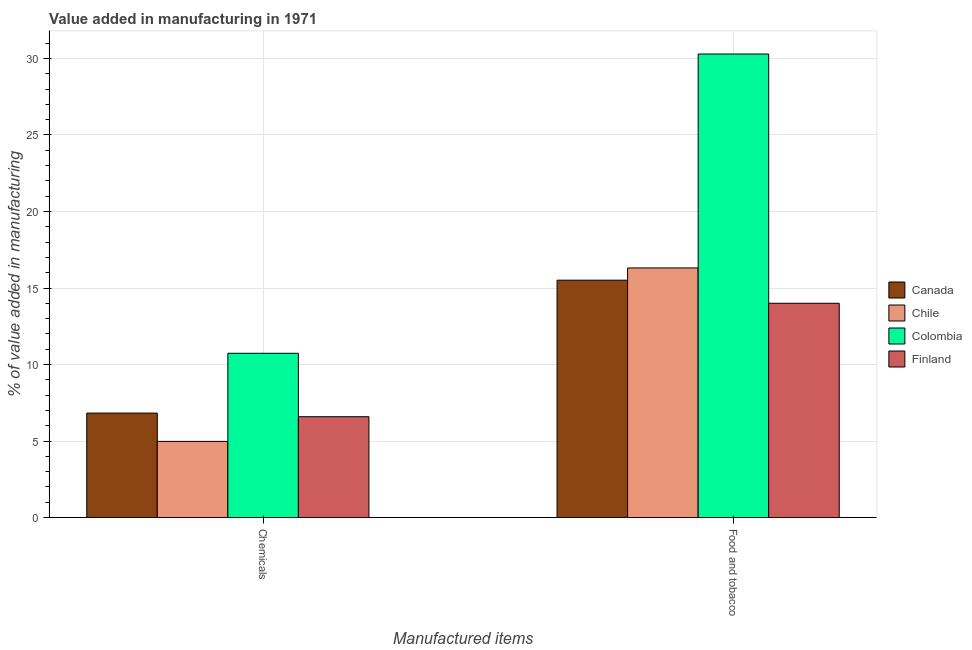How many different coloured bars are there?
Your answer should be very brief. 4. How many bars are there on the 2nd tick from the right?
Offer a terse response. 4. What is the label of the 1st group of bars from the left?
Provide a short and direct response. Chemicals. What is the value added by  manufacturing chemicals in Canada?
Ensure brevity in your answer.  6.83. Across all countries, what is the maximum value added by manufacturing food and tobacco?
Your response must be concise. 30.29. Across all countries, what is the minimum value added by manufacturing food and tobacco?
Ensure brevity in your answer.  14. In which country was the value added by  manufacturing chemicals maximum?
Your response must be concise. Colombia. In which country was the value added by  manufacturing chemicals minimum?
Give a very brief answer. Chile. What is the total value added by  manufacturing chemicals in the graph?
Your response must be concise. 29.13. What is the difference between the value added by manufacturing food and tobacco in Colombia and that in Canada?
Your response must be concise. 14.78. What is the difference between the value added by  manufacturing chemicals in Canada and the value added by manufacturing food and tobacco in Finland?
Give a very brief answer. -7.18. What is the average value added by  manufacturing chemicals per country?
Make the answer very short. 7.28. What is the difference between the value added by  manufacturing chemicals and value added by manufacturing food and tobacco in Finland?
Offer a very short reply. -7.41. In how many countries, is the value added by manufacturing food and tobacco greater than 6 %?
Give a very brief answer. 4. What is the ratio of the value added by  manufacturing chemicals in Chile to that in Colombia?
Give a very brief answer. 0.46. In how many countries, is the value added by manufacturing food and tobacco greater than the average value added by manufacturing food and tobacco taken over all countries?
Your response must be concise. 1. What does the 2nd bar from the left in Chemicals represents?
Provide a short and direct response. Chile. How many bars are there?
Make the answer very short. 8. What is the difference between two consecutive major ticks on the Y-axis?
Offer a terse response. 5. Does the graph contain grids?
Keep it short and to the point. Yes. What is the title of the graph?
Offer a very short reply. Value added in manufacturing in 1971. What is the label or title of the X-axis?
Offer a very short reply. Manufactured items. What is the label or title of the Y-axis?
Keep it short and to the point. % of value added in manufacturing. What is the % of value added in manufacturing of Canada in Chemicals?
Provide a short and direct response. 6.83. What is the % of value added in manufacturing in Chile in Chemicals?
Your answer should be compact. 4.98. What is the % of value added in manufacturing of Colombia in Chemicals?
Keep it short and to the point. 10.73. What is the % of value added in manufacturing of Finland in Chemicals?
Keep it short and to the point. 6.59. What is the % of value added in manufacturing in Canada in Food and tobacco?
Ensure brevity in your answer.  15.51. What is the % of value added in manufacturing in Chile in Food and tobacco?
Make the answer very short. 16.31. What is the % of value added in manufacturing of Colombia in Food and tobacco?
Ensure brevity in your answer.  30.29. What is the % of value added in manufacturing in Finland in Food and tobacco?
Your response must be concise. 14. Across all Manufactured items, what is the maximum % of value added in manufacturing in Canada?
Keep it short and to the point. 15.51. Across all Manufactured items, what is the maximum % of value added in manufacturing in Chile?
Ensure brevity in your answer.  16.31. Across all Manufactured items, what is the maximum % of value added in manufacturing of Colombia?
Give a very brief answer. 30.29. Across all Manufactured items, what is the maximum % of value added in manufacturing of Finland?
Your response must be concise. 14. Across all Manufactured items, what is the minimum % of value added in manufacturing of Canada?
Offer a terse response. 6.83. Across all Manufactured items, what is the minimum % of value added in manufacturing in Chile?
Keep it short and to the point. 4.98. Across all Manufactured items, what is the minimum % of value added in manufacturing in Colombia?
Make the answer very short. 10.73. Across all Manufactured items, what is the minimum % of value added in manufacturing of Finland?
Your response must be concise. 6.59. What is the total % of value added in manufacturing in Canada in the graph?
Offer a very short reply. 22.34. What is the total % of value added in manufacturing in Chile in the graph?
Keep it short and to the point. 21.29. What is the total % of value added in manufacturing of Colombia in the graph?
Give a very brief answer. 41.03. What is the total % of value added in manufacturing in Finland in the graph?
Make the answer very short. 20.59. What is the difference between the % of value added in manufacturing of Canada in Chemicals and that in Food and tobacco?
Your answer should be very brief. -8.69. What is the difference between the % of value added in manufacturing in Chile in Chemicals and that in Food and tobacco?
Your answer should be compact. -11.34. What is the difference between the % of value added in manufacturing of Colombia in Chemicals and that in Food and tobacco?
Your answer should be compact. -19.56. What is the difference between the % of value added in manufacturing of Finland in Chemicals and that in Food and tobacco?
Provide a succinct answer. -7.41. What is the difference between the % of value added in manufacturing of Canada in Chemicals and the % of value added in manufacturing of Chile in Food and tobacco?
Offer a terse response. -9.49. What is the difference between the % of value added in manufacturing of Canada in Chemicals and the % of value added in manufacturing of Colombia in Food and tobacco?
Provide a short and direct response. -23.47. What is the difference between the % of value added in manufacturing of Canada in Chemicals and the % of value added in manufacturing of Finland in Food and tobacco?
Provide a succinct answer. -7.18. What is the difference between the % of value added in manufacturing in Chile in Chemicals and the % of value added in manufacturing in Colombia in Food and tobacco?
Offer a very short reply. -25.32. What is the difference between the % of value added in manufacturing of Chile in Chemicals and the % of value added in manufacturing of Finland in Food and tobacco?
Make the answer very short. -9.03. What is the difference between the % of value added in manufacturing in Colombia in Chemicals and the % of value added in manufacturing in Finland in Food and tobacco?
Your response must be concise. -3.27. What is the average % of value added in manufacturing of Canada per Manufactured items?
Keep it short and to the point. 11.17. What is the average % of value added in manufacturing of Chile per Manufactured items?
Offer a very short reply. 10.64. What is the average % of value added in manufacturing of Colombia per Manufactured items?
Offer a very short reply. 20.51. What is the average % of value added in manufacturing of Finland per Manufactured items?
Offer a very short reply. 10.3. What is the difference between the % of value added in manufacturing in Canada and % of value added in manufacturing in Chile in Chemicals?
Offer a terse response. 1.85. What is the difference between the % of value added in manufacturing of Canada and % of value added in manufacturing of Colombia in Chemicals?
Your answer should be compact. -3.91. What is the difference between the % of value added in manufacturing of Canada and % of value added in manufacturing of Finland in Chemicals?
Give a very brief answer. 0.24. What is the difference between the % of value added in manufacturing of Chile and % of value added in manufacturing of Colombia in Chemicals?
Make the answer very short. -5.76. What is the difference between the % of value added in manufacturing in Chile and % of value added in manufacturing in Finland in Chemicals?
Provide a short and direct response. -1.61. What is the difference between the % of value added in manufacturing in Colombia and % of value added in manufacturing in Finland in Chemicals?
Keep it short and to the point. 4.15. What is the difference between the % of value added in manufacturing of Canada and % of value added in manufacturing of Chile in Food and tobacco?
Provide a short and direct response. -0.8. What is the difference between the % of value added in manufacturing of Canada and % of value added in manufacturing of Colombia in Food and tobacco?
Your response must be concise. -14.78. What is the difference between the % of value added in manufacturing in Canada and % of value added in manufacturing in Finland in Food and tobacco?
Keep it short and to the point. 1.51. What is the difference between the % of value added in manufacturing in Chile and % of value added in manufacturing in Colombia in Food and tobacco?
Provide a short and direct response. -13.98. What is the difference between the % of value added in manufacturing of Chile and % of value added in manufacturing of Finland in Food and tobacco?
Offer a very short reply. 2.31. What is the difference between the % of value added in manufacturing of Colombia and % of value added in manufacturing of Finland in Food and tobacco?
Give a very brief answer. 16.29. What is the ratio of the % of value added in manufacturing in Canada in Chemicals to that in Food and tobacco?
Your answer should be very brief. 0.44. What is the ratio of the % of value added in manufacturing of Chile in Chemicals to that in Food and tobacco?
Offer a terse response. 0.31. What is the ratio of the % of value added in manufacturing in Colombia in Chemicals to that in Food and tobacco?
Offer a terse response. 0.35. What is the ratio of the % of value added in manufacturing in Finland in Chemicals to that in Food and tobacco?
Your response must be concise. 0.47. What is the difference between the highest and the second highest % of value added in manufacturing of Canada?
Ensure brevity in your answer.  8.69. What is the difference between the highest and the second highest % of value added in manufacturing of Chile?
Give a very brief answer. 11.34. What is the difference between the highest and the second highest % of value added in manufacturing in Colombia?
Offer a very short reply. 19.56. What is the difference between the highest and the second highest % of value added in manufacturing in Finland?
Your answer should be compact. 7.41. What is the difference between the highest and the lowest % of value added in manufacturing of Canada?
Your answer should be very brief. 8.69. What is the difference between the highest and the lowest % of value added in manufacturing of Chile?
Provide a succinct answer. 11.34. What is the difference between the highest and the lowest % of value added in manufacturing in Colombia?
Offer a very short reply. 19.56. What is the difference between the highest and the lowest % of value added in manufacturing in Finland?
Keep it short and to the point. 7.41. 